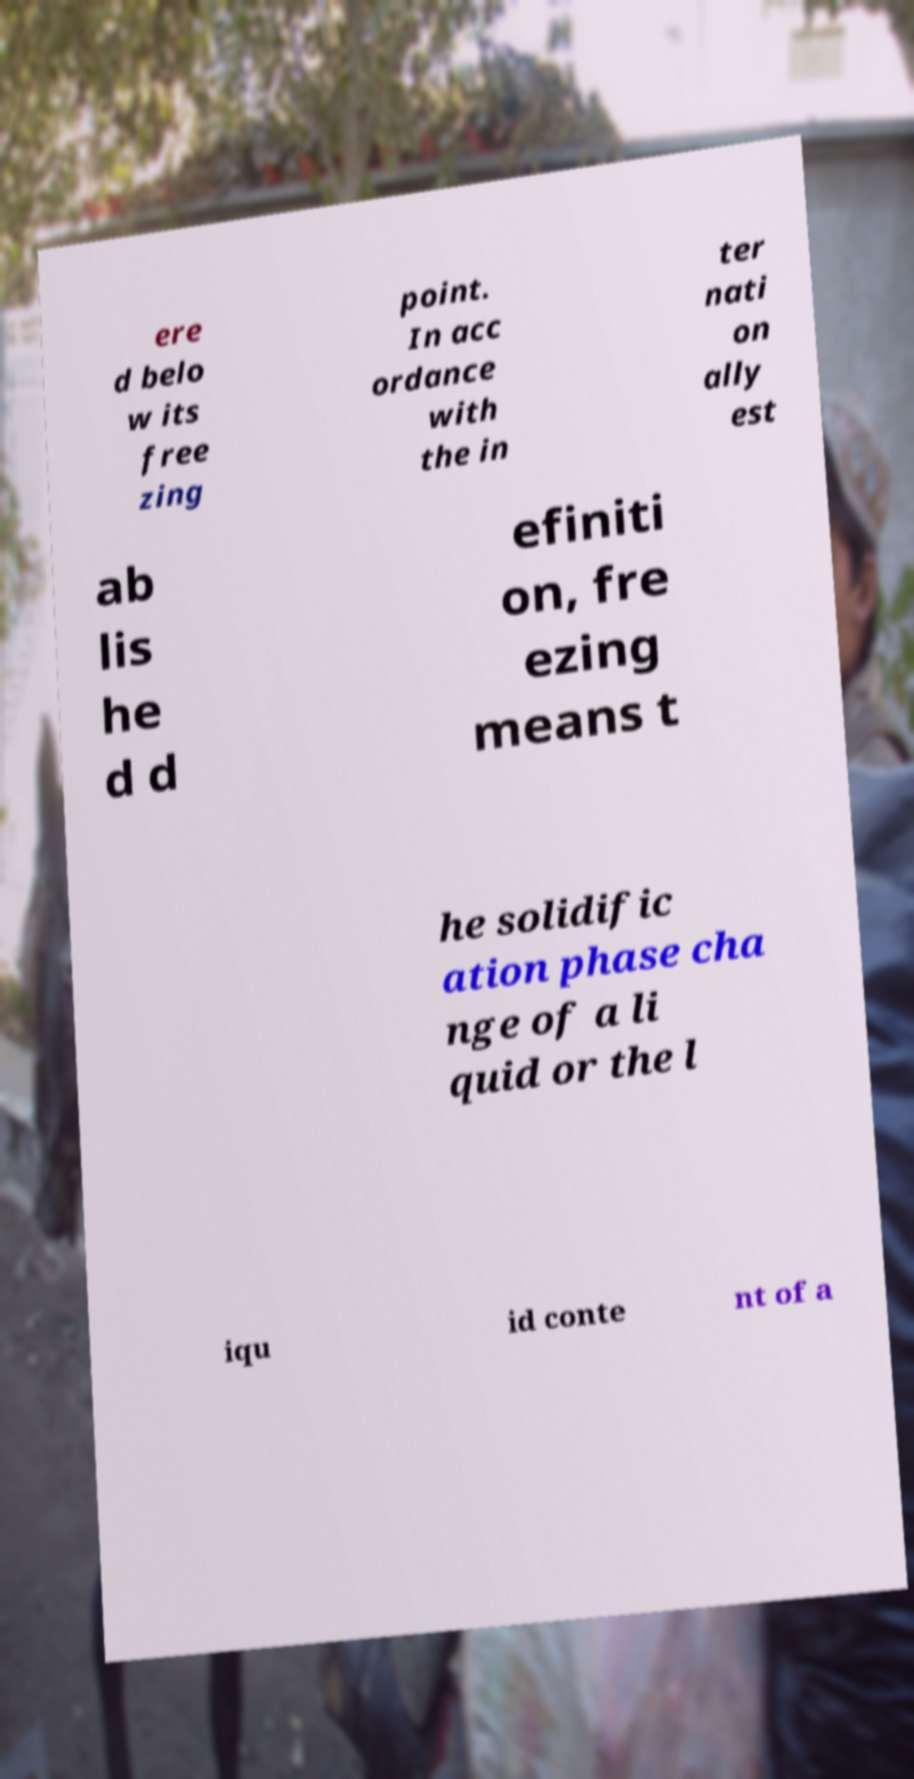There's text embedded in this image that I need extracted. Can you transcribe it verbatim? ere d belo w its free zing point. In acc ordance with the in ter nati on ally est ab lis he d d efiniti on, fre ezing means t he solidific ation phase cha nge of a li quid or the l iqu id conte nt of a 